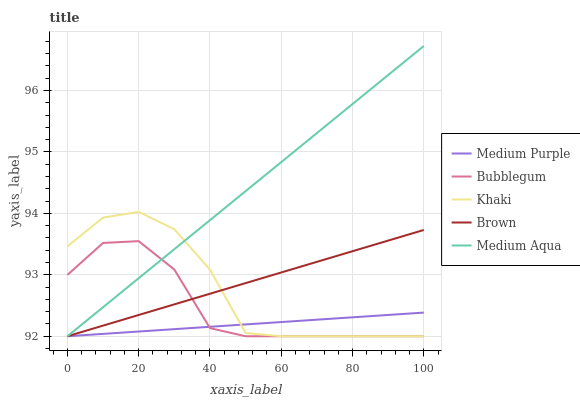Does Medium Purple have the minimum area under the curve?
Answer yes or no. Yes. Does Medium Aqua have the maximum area under the curve?
Answer yes or no. Yes. Does Brown have the minimum area under the curve?
Answer yes or no. No. Does Brown have the maximum area under the curve?
Answer yes or no. No. Is Medium Aqua the smoothest?
Answer yes or no. Yes. Is Khaki the roughest?
Answer yes or no. Yes. Is Brown the smoothest?
Answer yes or no. No. Is Brown the roughest?
Answer yes or no. No. Does Medium Purple have the lowest value?
Answer yes or no. Yes. Does Medium Aqua have the highest value?
Answer yes or no. Yes. Does Brown have the highest value?
Answer yes or no. No. Does Medium Purple intersect Medium Aqua?
Answer yes or no. Yes. Is Medium Purple less than Medium Aqua?
Answer yes or no. No. Is Medium Purple greater than Medium Aqua?
Answer yes or no. No. 